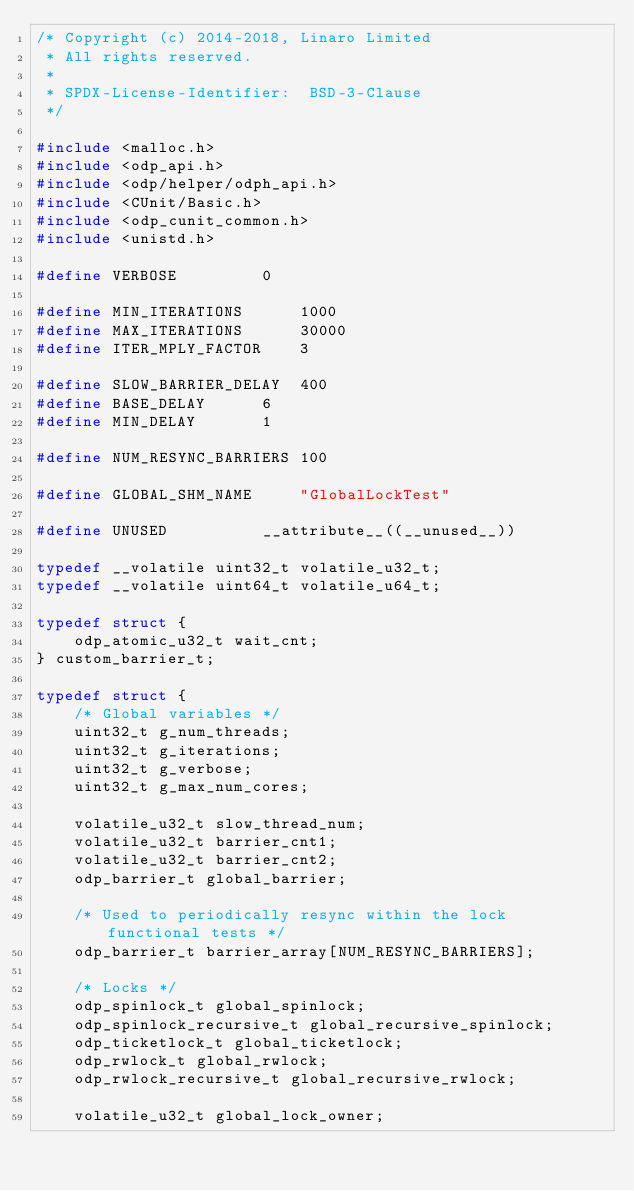Convert code to text. <code><loc_0><loc_0><loc_500><loc_500><_C_>/* Copyright (c) 2014-2018, Linaro Limited
 * All rights reserved.
 *
 * SPDX-License-Identifier:	 BSD-3-Clause
 */

#include <malloc.h>
#include <odp_api.h>
#include <odp/helper/odph_api.h>
#include <CUnit/Basic.h>
#include <odp_cunit_common.h>
#include <unistd.h>

#define VERBOSE			0

#define MIN_ITERATIONS		1000
#define MAX_ITERATIONS		30000
#define ITER_MPLY_FACTOR	3

#define SLOW_BARRIER_DELAY	400
#define BASE_DELAY		6
#define MIN_DELAY		1

#define NUM_RESYNC_BARRIERS	100

#define GLOBAL_SHM_NAME		"GlobalLockTest"

#define UNUSED			__attribute__((__unused__))

typedef __volatile uint32_t volatile_u32_t;
typedef __volatile uint64_t volatile_u64_t;

typedef struct {
	odp_atomic_u32_t wait_cnt;
} custom_barrier_t;

typedef struct {
	/* Global variables */
	uint32_t g_num_threads;
	uint32_t g_iterations;
	uint32_t g_verbose;
	uint32_t g_max_num_cores;

	volatile_u32_t slow_thread_num;
	volatile_u32_t barrier_cnt1;
	volatile_u32_t barrier_cnt2;
	odp_barrier_t global_barrier;

	/* Used to periodically resync within the lock functional tests */
	odp_barrier_t barrier_array[NUM_RESYNC_BARRIERS];

	/* Locks */
	odp_spinlock_t global_spinlock;
	odp_spinlock_recursive_t global_recursive_spinlock;
	odp_ticketlock_t global_ticketlock;
	odp_rwlock_t global_rwlock;
	odp_rwlock_recursive_t global_recursive_rwlock;

	volatile_u32_t global_lock_owner;</code> 